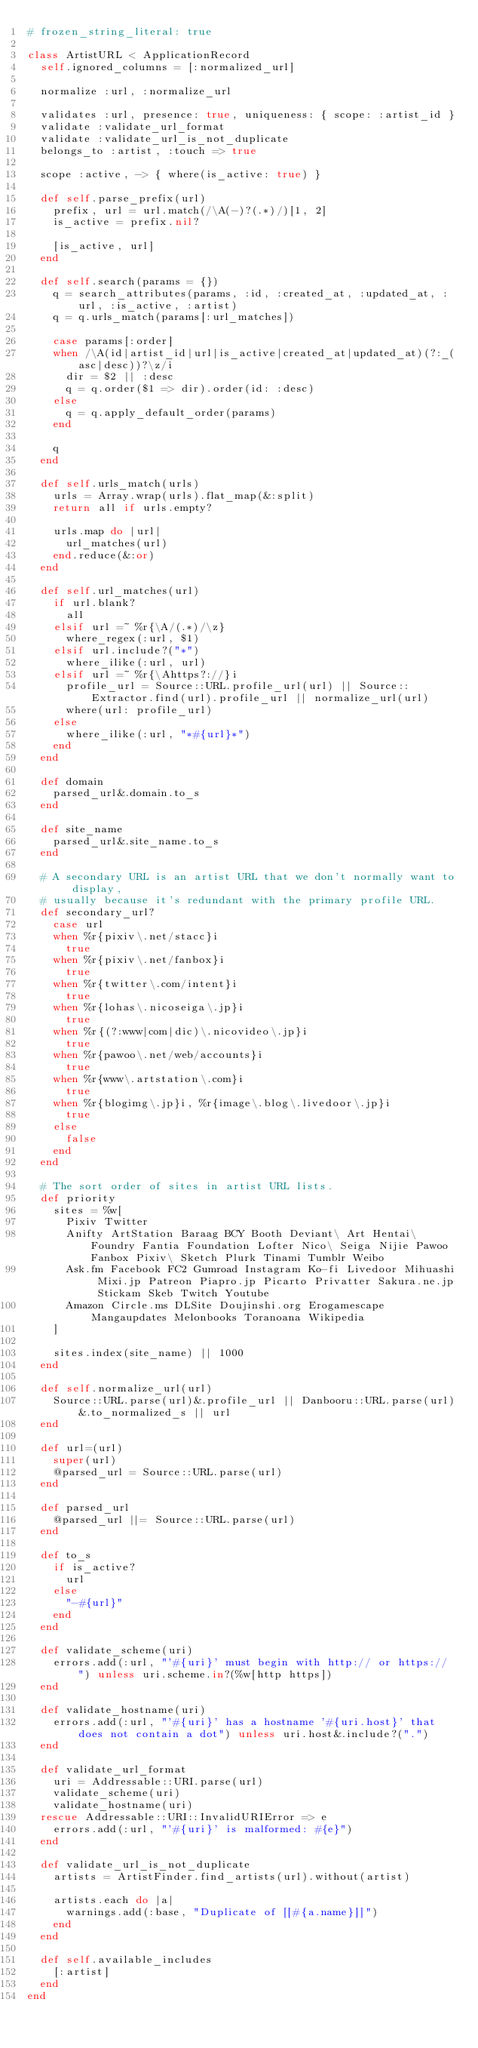<code> <loc_0><loc_0><loc_500><loc_500><_Ruby_># frozen_string_literal: true

class ArtistURL < ApplicationRecord
  self.ignored_columns = [:normalized_url]

  normalize :url, :normalize_url

  validates :url, presence: true, uniqueness: { scope: :artist_id }
  validate :validate_url_format
  validate :validate_url_is_not_duplicate
  belongs_to :artist, :touch => true

  scope :active, -> { where(is_active: true) }

  def self.parse_prefix(url)
    prefix, url = url.match(/\A(-)?(.*)/)[1, 2]
    is_active = prefix.nil?

    [is_active, url]
  end

  def self.search(params = {})
    q = search_attributes(params, :id, :created_at, :updated_at, :url, :is_active, :artist)
    q = q.urls_match(params[:url_matches])

    case params[:order]
    when /\A(id|artist_id|url|is_active|created_at|updated_at)(?:_(asc|desc))?\z/i
      dir = $2 || :desc
      q = q.order($1 => dir).order(id: :desc)
    else
      q = q.apply_default_order(params)
    end

    q
  end

  def self.urls_match(urls)
    urls = Array.wrap(urls).flat_map(&:split)
    return all if urls.empty?

    urls.map do |url|
      url_matches(url)
    end.reduce(&:or)
  end

  def self.url_matches(url)
    if url.blank?
      all
    elsif url =~ %r{\A/(.*)/\z}
      where_regex(:url, $1)
    elsif url.include?("*")
      where_ilike(:url, url)
    elsif url =~ %r{\Ahttps?://}i
      profile_url = Source::URL.profile_url(url) || Source::Extractor.find(url).profile_url || normalize_url(url)
      where(url: profile_url)
    else
      where_ilike(:url, "*#{url}*")
    end
  end

  def domain
    parsed_url&.domain.to_s
  end

  def site_name
    parsed_url&.site_name.to_s
  end

  # A secondary URL is an artist URL that we don't normally want to display,
  # usually because it's redundant with the primary profile URL.
  def secondary_url?
    case url
    when %r{pixiv\.net/stacc}i
      true
    when %r{pixiv\.net/fanbox}i
      true
    when %r{twitter\.com/intent}i
      true
    when %r{lohas\.nicoseiga\.jp}i
      true
    when %r{(?:www|com|dic)\.nicovideo\.jp}i
      true
    when %r{pawoo\.net/web/accounts}i
      true
    when %r{www\.artstation\.com}i
      true
    when %r{blogimg\.jp}i, %r{image\.blog\.livedoor\.jp}i
      true
    else
      false
    end
  end

  # The sort order of sites in artist URL lists.
  def priority
    sites = %w[
      Pixiv Twitter
      Anifty ArtStation Baraag BCY Booth Deviant\ Art Hentai\ Foundry Fantia Foundation Lofter Nico\ Seiga Nijie Pawoo Fanbox Pixiv\ Sketch Plurk Tinami Tumblr Weibo
      Ask.fm Facebook FC2 Gumroad Instagram Ko-fi Livedoor Mihuashi Mixi.jp Patreon Piapro.jp Picarto Privatter Sakura.ne.jp Stickam Skeb Twitch Youtube
      Amazon Circle.ms DLSite Doujinshi.org Erogamescape Mangaupdates Melonbooks Toranoana Wikipedia
    ]

    sites.index(site_name) || 1000
  end

  def self.normalize_url(url)
    Source::URL.parse(url)&.profile_url || Danbooru::URL.parse(url)&.to_normalized_s || url
  end

  def url=(url)
    super(url)
    @parsed_url = Source::URL.parse(url)
  end

  def parsed_url
    @parsed_url ||= Source::URL.parse(url)
  end

  def to_s
    if is_active?
      url
    else
      "-#{url}"
    end
  end

  def validate_scheme(uri)
    errors.add(:url, "'#{uri}' must begin with http:// or https:// ") unless uri.scheme.in?(%w[http https])
  end

  def validate_hostname(uri)
    errors.add(:url, "'#{uri}' has a hostname '#{uri.host}' that does not contain a dot") unless uri.host&.include?(".")
  end

  def validate_url_format
    uri = Addressable::URI.parse(url)
    validate_scheme(uri)
    validate_hostname(uri)
  rescue Addressable::URI::InvalidURIError => e
    errors.add(:url, "'#{uri}' is malformed: #{e}")
  end

  def validate_url_is_not_duplicate
    artists = ArtistFinder.find_artists(url).without(artist)

    artists.each do |a|
      warnings.add(:base, "Duplicate of [[#{a.name}]]")
    end
  end

  def self.available_includes
    [:artist]
  end
end
</code> 